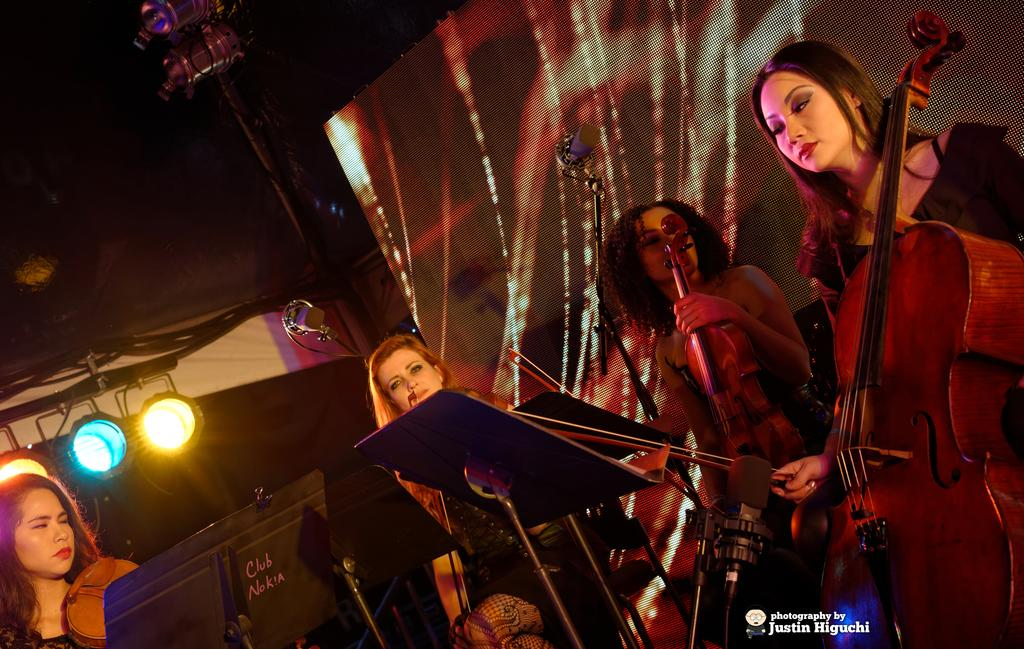What is happening in the image? There is a group of people in the image, and they are playing musical instruments. What are the people in the image doing? The group of people are playing musical instruments. What type of thread is being used to play the musical instruments in the image? There is no thread present in the image, and the musical instruments are not being played with thread. 